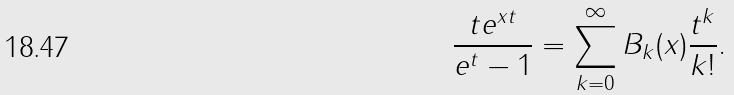Convert formula to latex. <formula><loc_0><loc_0><loc_500><loc_500>\frac { t e ^ { x t } } { e ^ { t } - 1 } = \sum _ { k = 0 } ^ { \infty } B _ { k } ( x ) \frac { t ^ { k } } { k ! } .</formula> 